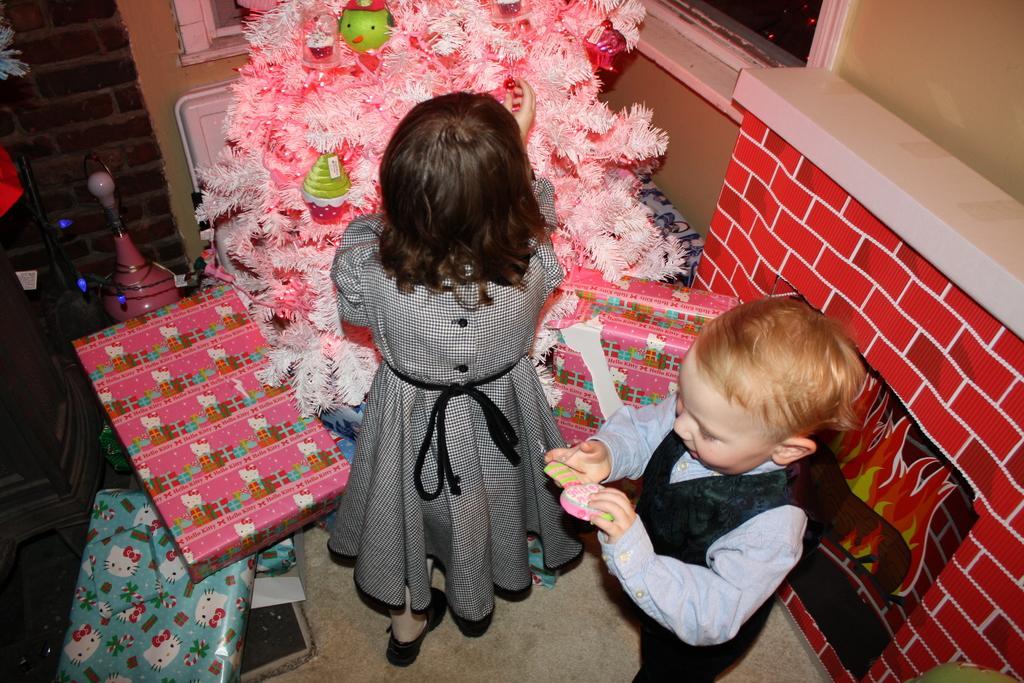In one or two sentences, can you explain what this image depicts? In the picture I can see two kids are standing on the floor. In the background I can see a wall, a tree, boxes and some other objects. 